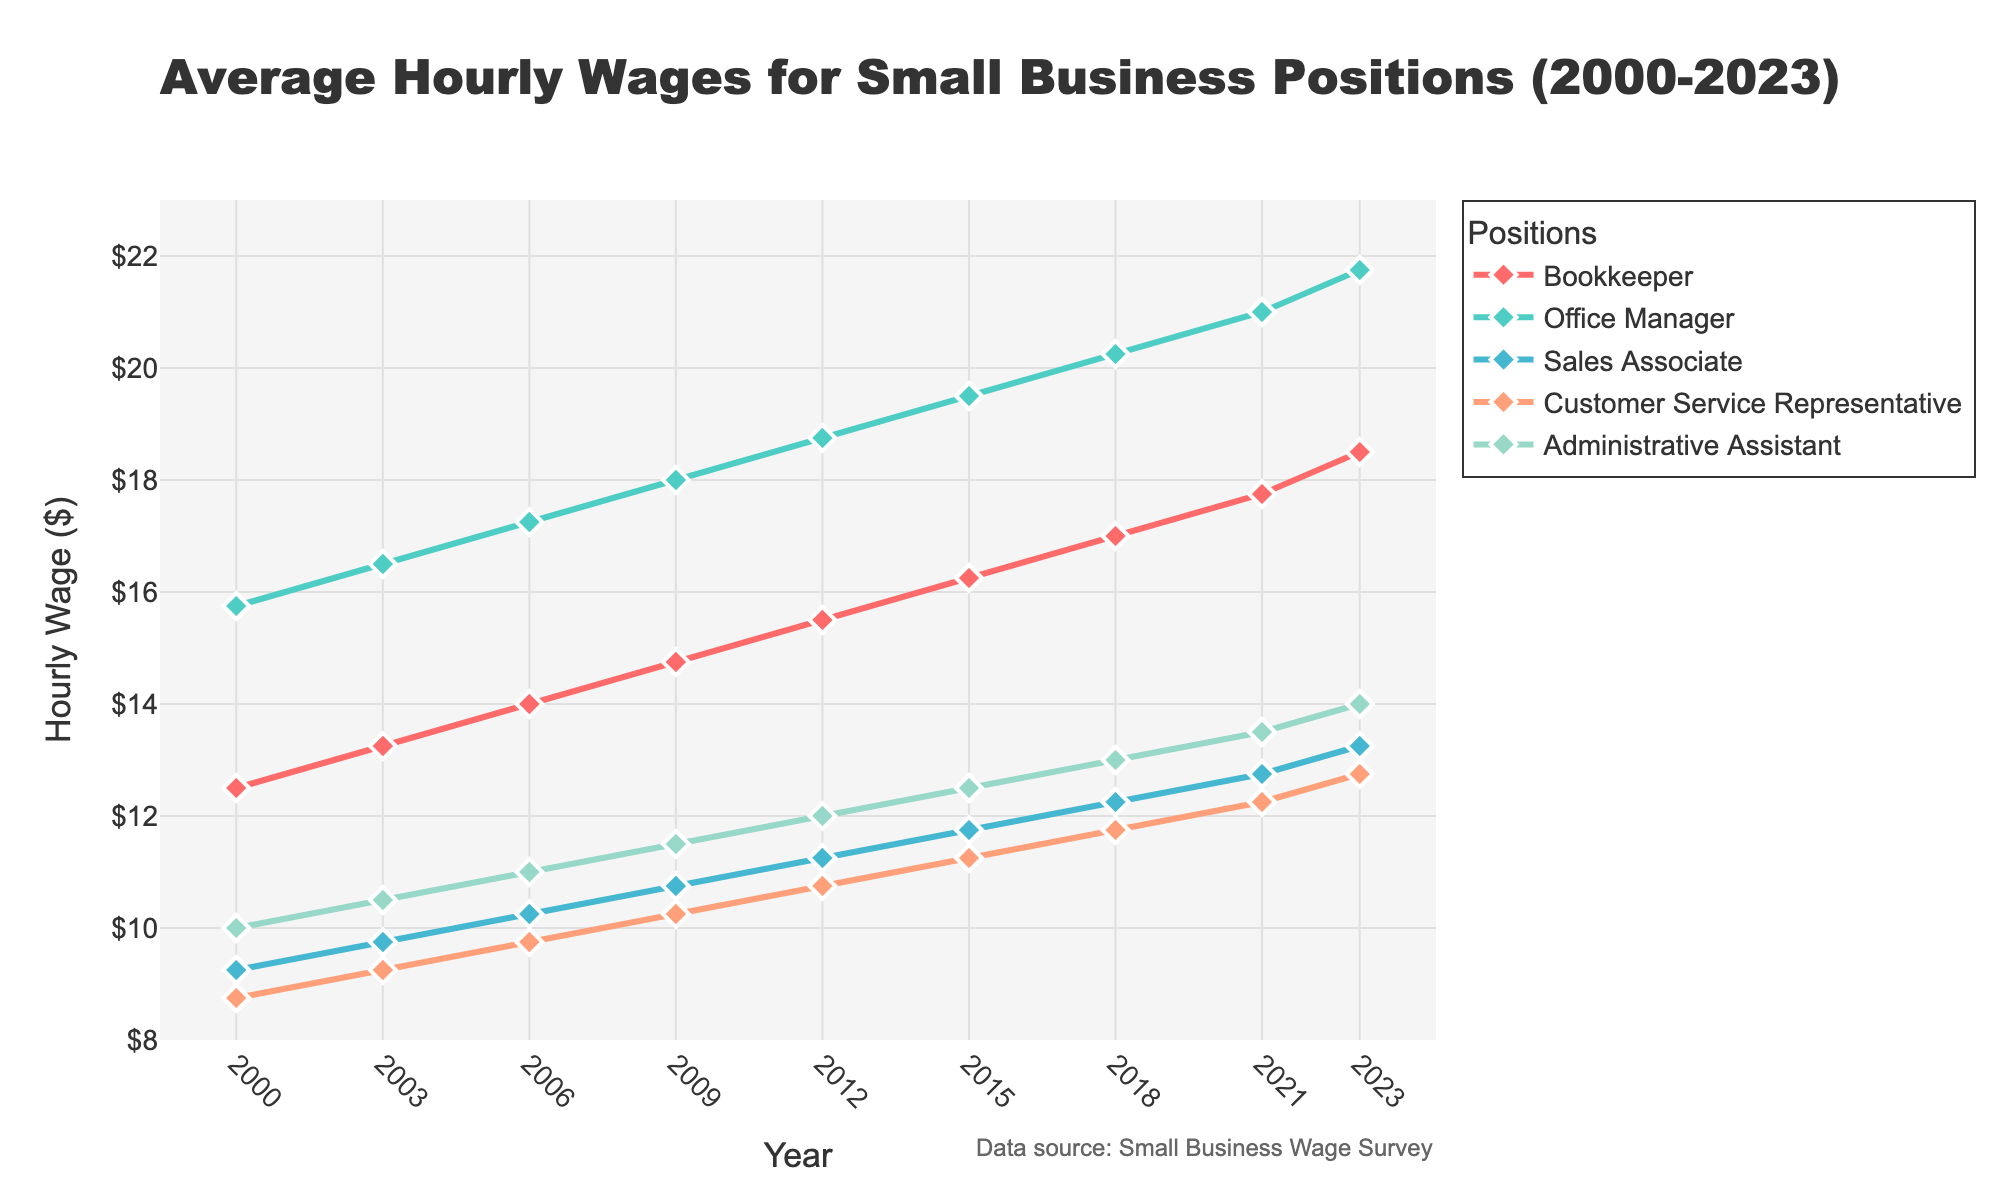what was the average hourly wage for Customer Service Representatives in 2010 and in 2020? Refer to the figure to find the wages for 2009 and 2021 (since 2010 and 2020 were not sampled). In 2009, it was $10.25 and in 2021, it was $12.25. Take the average: (10.25 + 12.25) / 2
Answer: $11.25 which position had the highest wage increase from 2000 to 2023? Look at the starting and ending points for each position. Calculate the increase for Bookkeeper (18.50 - 12.50), Office Manager (21.75 - 15.75), Sales Associate (13.25 - 9.25), Customer Service Representative (12.75 - 8.75), and Administrative Assistant (14.00 - 10.00). The highest increase is for Office Manager
Answer: Office Manager did Sales Associates' wages ever exceed Administrative Assistants' wages from 2000 to 2023? Refer to the figure and compare the lines: Administrative Assistants always had a higher wage than Sales Associates in all sampled years
Answer: No in which year did Bookkeepers earn the same hourly wage as Administrative Assistants? Refer to the figure to find the intersection of the Bookkeeper and Administrative Assistant lines. In 2006, both earned $14.00
Answer: 2006 order the positions from the highest to lowest average hourly wage in 2023 Look at the endpoint of each line for 2023: Office Manager (21.75), Bookkeeper (18.50), Customer Service Representative (12.75), Sales Associate (13.25), Administrative Assistant (14.00). Arrange them in order
Answer: Office Manager, Bookkeeper, Administrative Assistant, Sales Associate, Customer Service Representative what is the color of the line representing Sales Associates? Refer to the color of the lines in the figure. Sales Associates' line is represented in blue
Answer: Blue what was the average hourly wage increase for Administrative Assistants between 2000 and 2023? Find the starting and ending wages for Administrative Assistant. It increased from $10.00 to $14.00. Calculate the increase: (14.00 - 10.00) = 4.00. The average yearly increase is 4.00 / (2023 - 2000)
Answer: $0.174 each year which position had the smallest wage change between 2018 and 2021? Find the wage change for each position between 2018 and 2021. Bookkeeper (17.00 to 17.75), Office Manager (20.25 to 21.00), Sales Associate (12.25 to 12.75), Customer Service Representative (11.75 to 12.25), Administrative Assistant (13.00 to 13.50). The smallest increase is for Sales Associate (12.25 to 12.75)
Answer: Sales Associate compare the wage growth rate between Sales Associates and Customer Service Representatives? Sales Associates increased from $9.25 to $13.25 from 2000 to 2023, and Customer Service Representatives increased from $8.75 to $12.75 over the same period. Calculate growth rates: Sales Associates: (13.25 - 9.25) / 9.25 * 100%, Customer Service Representatives: (12.75 - 8.75) / 8.75 * 100%. Sales Associates had ~43.24% growth, Customer Service Representatives had ~45.71%
Answer: Customer Service Representatives grew faster what hourly wage was recorded for Office Managers in 2006, 2012, and 2018? Refer to the figure at the respective points for Office Managers. 2006: $17.25, 2012: $18.75, 2018: $20.25
Answer: $17.25 (2006), $18.75 (2012), $20.25 (2018) 